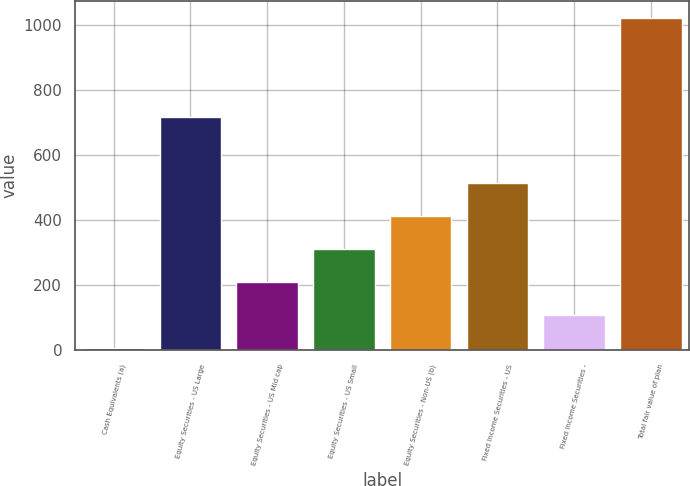Convert chart. <chart><loc_0><loc_0><loc_500><loc_500><bar_chart><fcel>Cash Equivalents (a)<fcel>Equity Securities - US Large<fcel>Equity Securities - US Mid cap<fcel>Equity Securities - US Small<fcel>Equity Securities - Non-US (b)<fcel>Fixed Income Securities - US<fcel>Fixed Income Securities -<fcel>Total fair value of plan<nl><fcel>9<fcel>719.5<fcel>212<fcel>313.5<fcel>415<fcel>516.5<fcel>110.5<fcel>1024<nl></chart> 